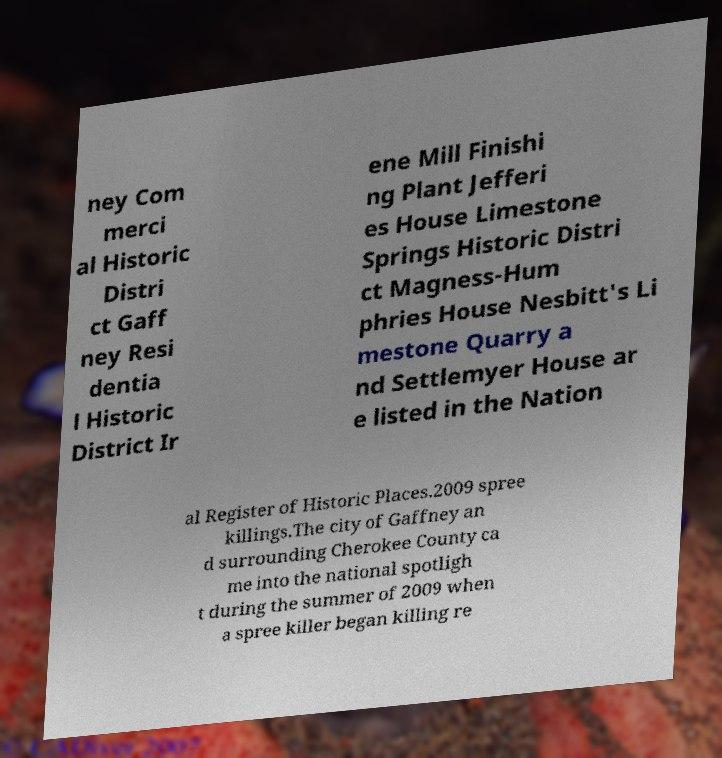Please identify and transcribe the text found in this image. ney Com merci al Historic Distri ct Gaff ney Resi dentia l Historic District Ir ene Mill Finishi ng Plant Jefferi es House Limestone Springs Historic Distri ct Magness-Hum phries House Nesbitt's Li mestone Quarry a nd Settlemyer House ar e listed in the Nation al Register of Historic Places.2009 spree killings.The city of Gaffney an d surrounding Cherokee County ca me into the national spotligh t during the summer of 2009 when a spree killer began killing re 